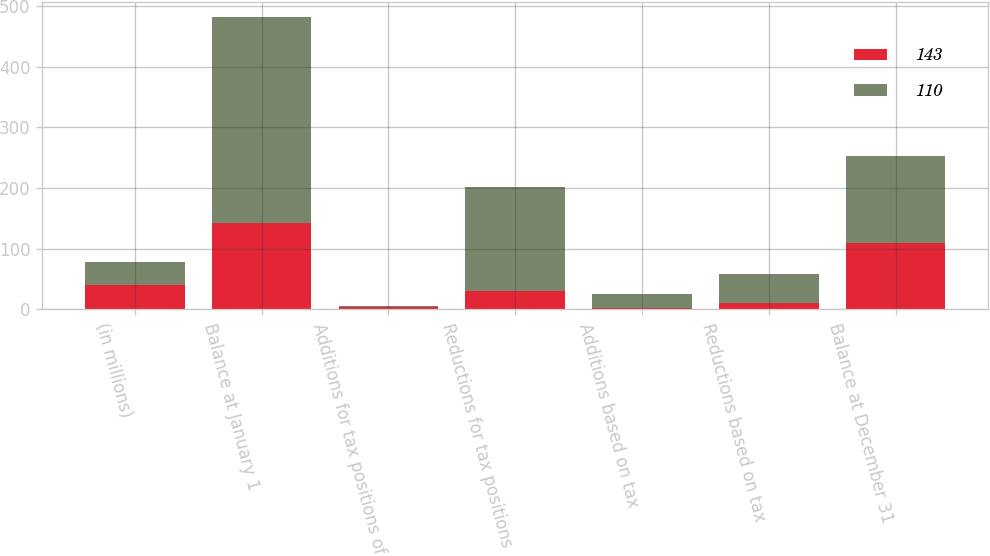<chart> <loc_0><loc_0><loc_500><loc_500><stacked_bar_chart><ecel><fcel>(in millions)<fcel>Balance at January 1<fcel>Additions for tax positions of<fcel>Reductions for tax positions<fcel>Additions based on tax<fcel>Reductions based on tax<fcel>Balance at December 31<nl><fcel>143<fcel>39.5<fcel>143<fcel>4<fcel>30<fcel>3<fcel>10<fcel>110<nl><fcel>110<fcel>39.5<fcel>339<fcel>2<fcel>172<fcel>23<fcel>49<fcel>143<nl></chart> 